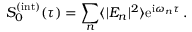<formula> <loc_0><loc_0><loc_500><loc_500>S _ { 0 } ^ { ( i n t ) } ( \tau ) = \sum _ { n } \langle | E _ { n } | ^ { 2 } \rangle e ^ { i \omega _ { n } \tau } \, .</formula> 